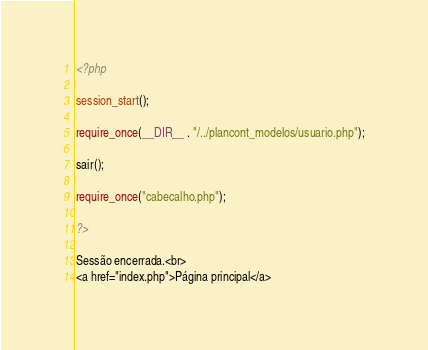<code> <loc_0><loc_0><loc_500><loc_500><_PHP_><?php

session_start();

require_once(__DIR__ . "/../plancont_modelos/usuario.php");

sair();

require_once("cabecalho.php");

?>

Sessão encerrada.<br>
<a href="index.php">Página principal</a>
</code> 